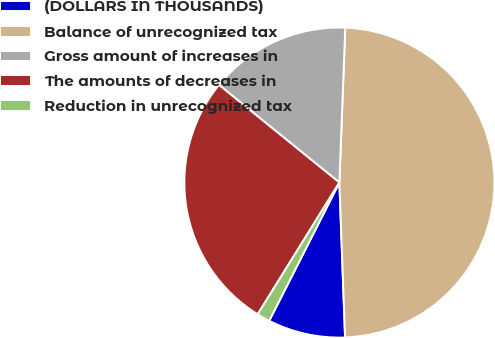Convert chart. <chart><loc_0><loc_0><loc_500><loc_500><pie_chart><fcel>(DOLLARS IN THOUSANDS)<fcel>Balance of unrecognized tax<fcel>Gross amount of increases in<fcel>The amounts of decreases in<fcel>Reduction in unrecognized tax<nl><fcel>8.06%<fcel>48.81%<fcel>14.76%<fcel>27.01%<fcel>1.36%<nl></chart> 